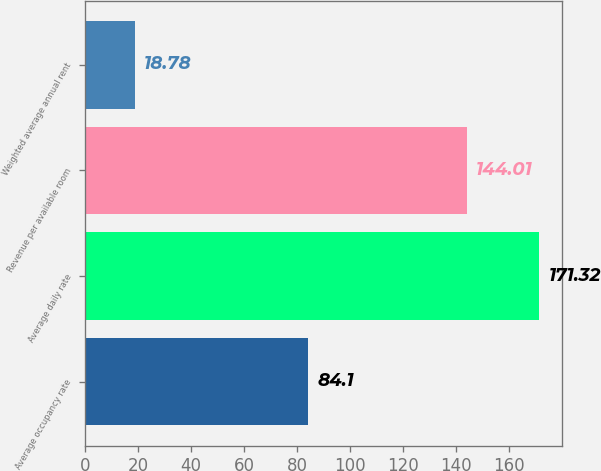<chart> <loc_0><loc_0><loc_500><loc_500><bar_chart><fcel>Average occupancy rate<fcel>Average daily rate<fcel>Revenue per available room<fcel>Weighted average annual rent<nl><fcel>84.1<fcel>171.32<fcel>144.01<fcel>18.78<nl></chart> 